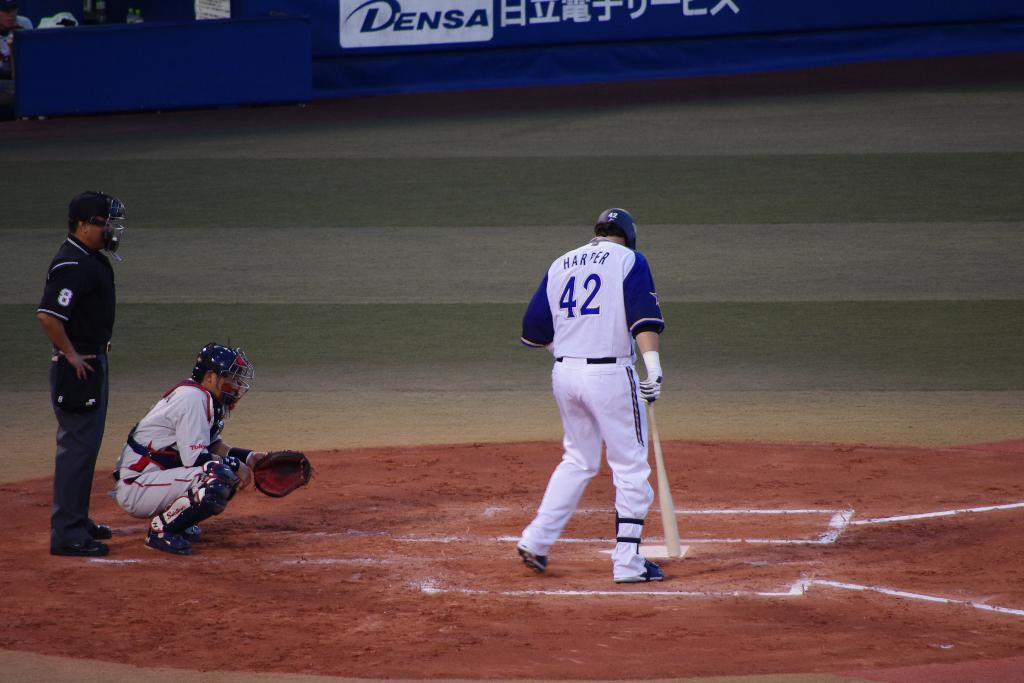<image>
Provide a brief description of the given image. A baseball player at the plate with Harter 42 on his shirt. 